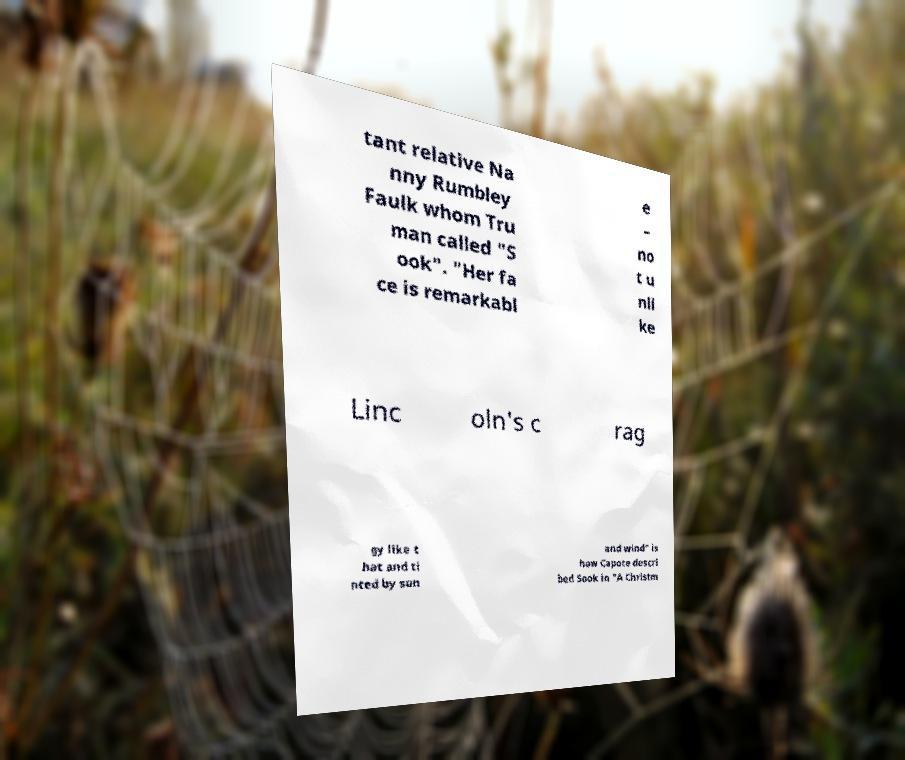For documentation purposes, I need the text within this image transcribed. Could you provide that? tant relative Na nny Rumbley Faulk whom Tru man called "S ook". "Her fa ce is remarkabl e – no t u nli ke Linc oln's c rag gy like t hat and ti nted by sun and wind" is how Capote descri bed Sook in "A Christm 